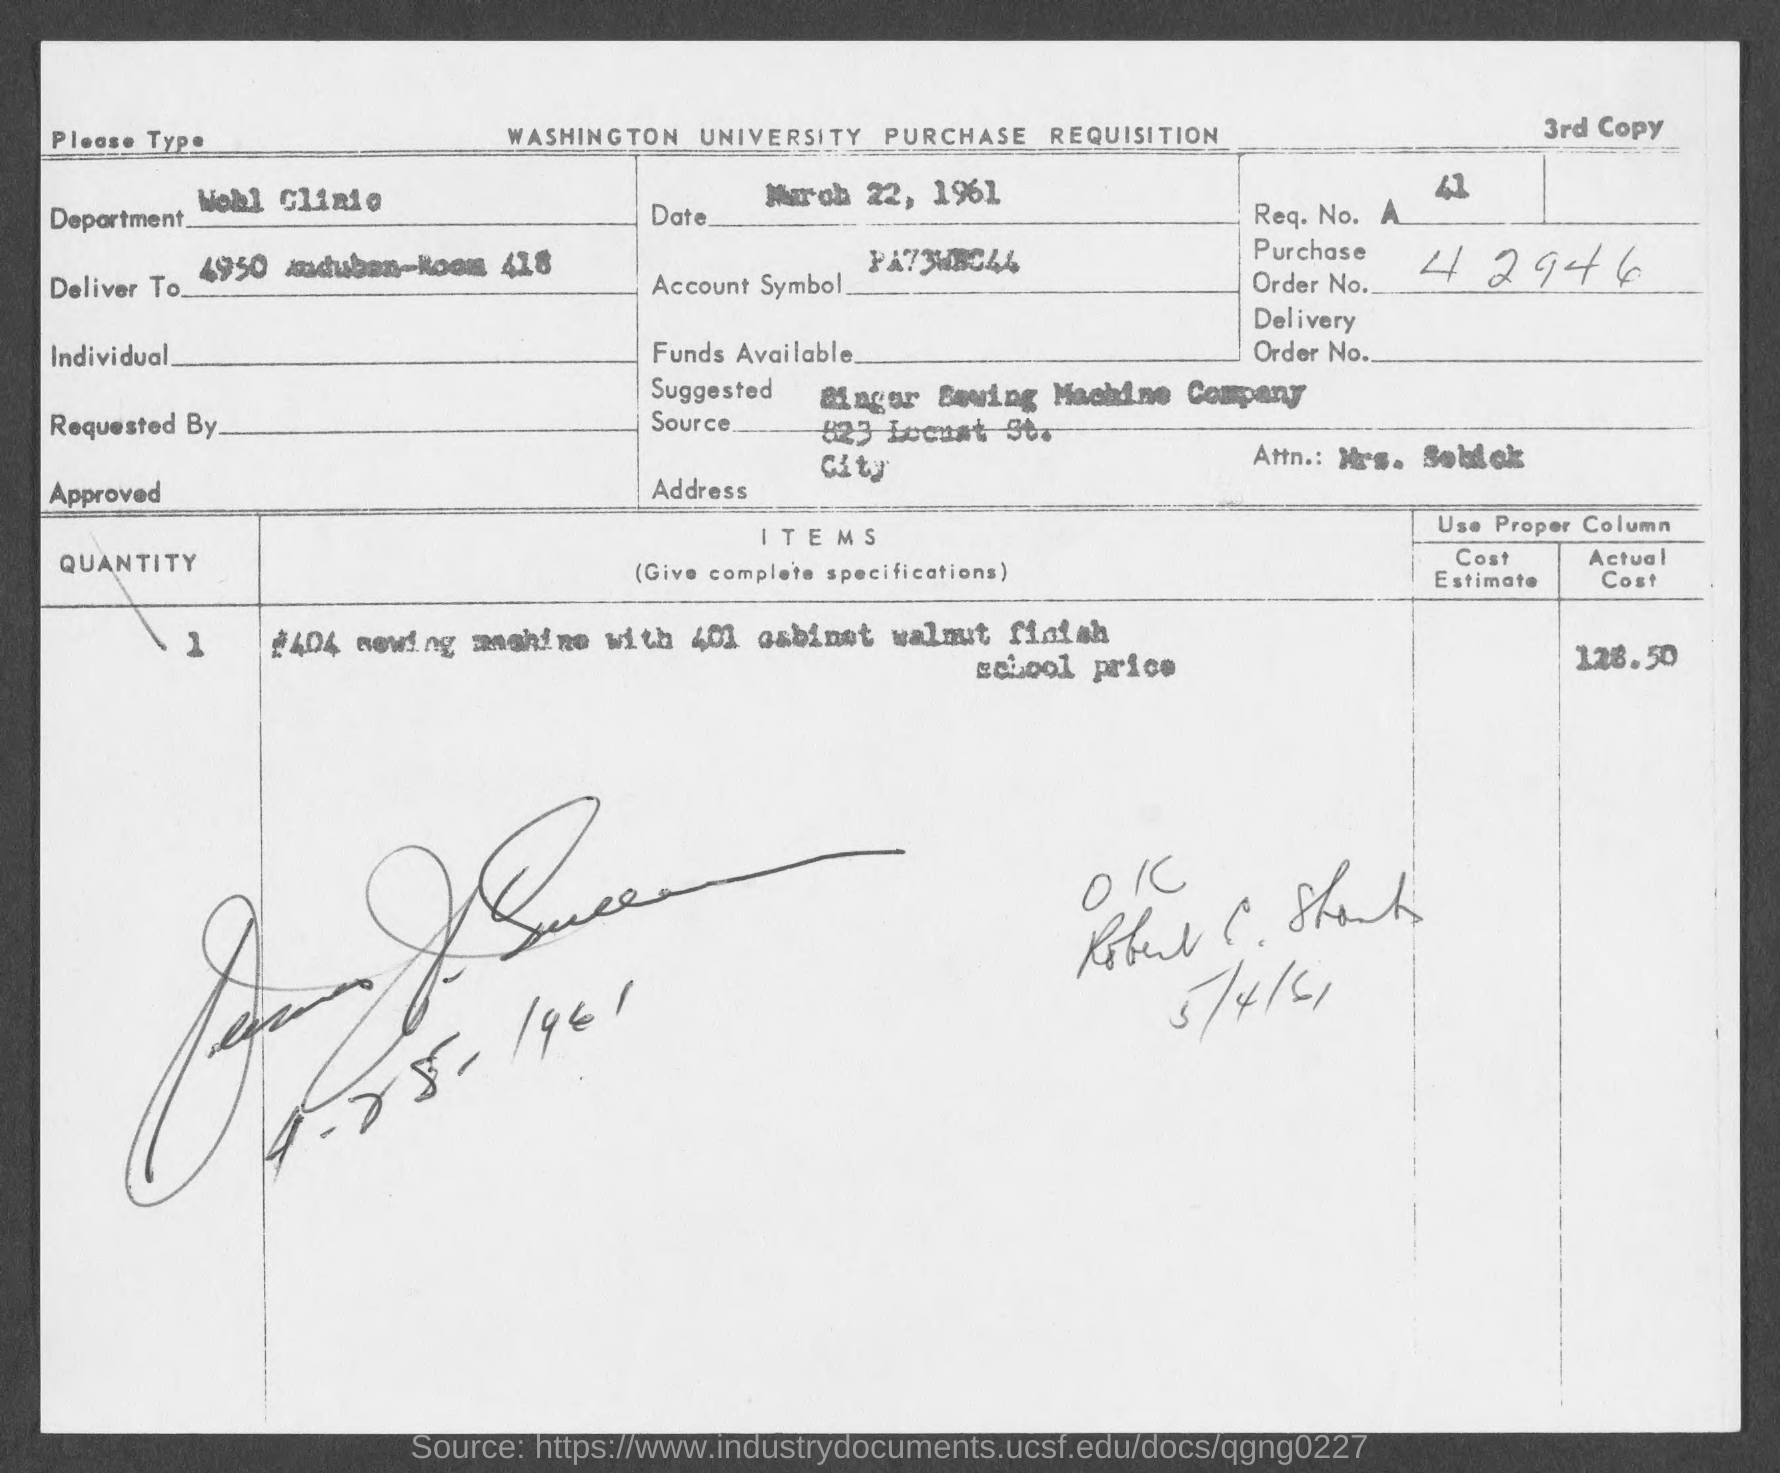Draw attention to some important aspects in this diagram. The purchase order number is 42946. 